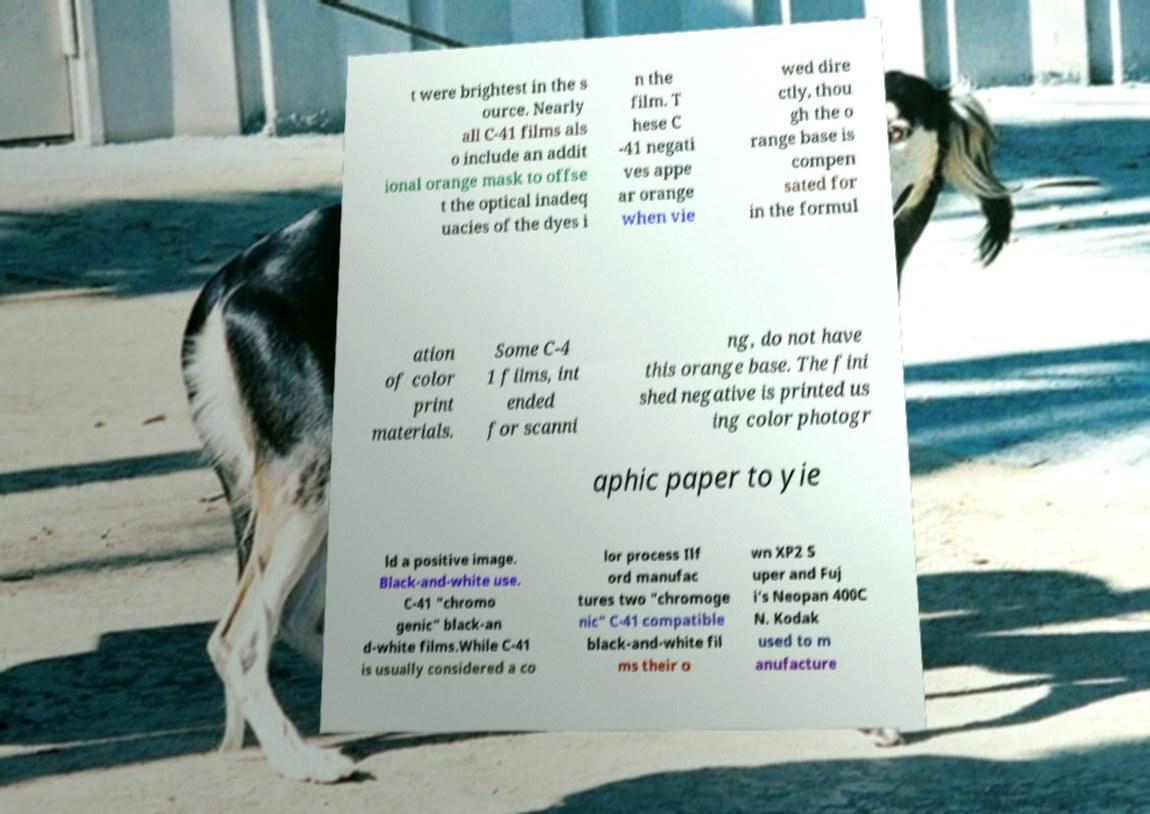I need the written content from this picture converted into text. Can you do that? t were brightest in the s ource. Nearly all C-41 films als o include an addit ional orange mask to offse t the optical inadeq uacies of the dyes i n the film. T hese C -41 negati ves appe ar orange when vie wed dire ctly, thou gh the o range base is compen sated for in the formul ation of color print materials. Some C-4 1 films, int ended for scanni ng, do not have this orange base. The fini shed negative is printed us ing color photogr aphic paper to yie ld a positive image. Black-and-white use. C-41 "chromo genic" black-an d-white films.While C-41 is usually considered a co lor process Ilf ord manufac tures two "chromoge nic" C-41 compatible black-and-white fil ms their o wn XP2 S uper and Fuj i's Neopan 400C N. Kodak used to m anufacture 